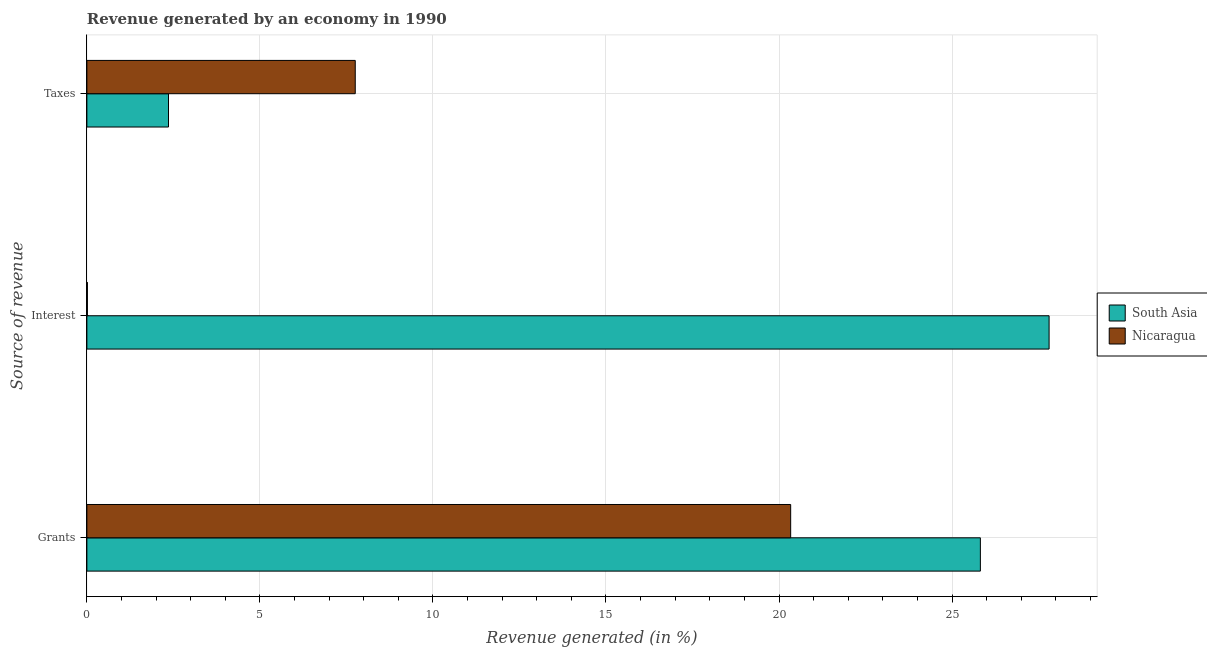How many different coloured bars are there?
Keep it short and to the point. 2. What is the label of the 3rd group of bars from the top?
Offer a very short reply. Grants. What is the percentage of revenue generated by taxes in Nicaragua?
Your response must be concise. 7.75. Across all countries, what is the maximum percentage of revenue generated by grants?
Your response must be concise. 25.82. Across all countries, what is the minimum percentage of revenue generated by taxes?
Your response must be concise. 2.36. In which country was the percentage of revenue generated by interest maximum?
Keep it short and to the point. South Asia. In which country was the percentage of revenue generated by interest minimum?
Your response must be concise. Nicaragua. What is the total percentage of revenue generated by interest in the graph?
Provide a succinct answer. 27.82. What is the difference between the percentage of revenue generated by interest in South Asia and that in Nicaragua?
Give a very brief answer. 27.79. What is the difference between the percentage of revenue generated by interest in Nicaragua and the percentage of revenue generated by grants in South Asia?
Provide a succinct answer. -25.8. What is the average percentage of revenue generated by grants per country?
Make the answer very short. 23.08. What is the difference between the percentage of revenue generated by grants and percentage of revenue generated by interest in Nicaragua?
Provide a succinct answer. 20.32. What is the ratio of the percentage of revenue generated by interest in South Asia to that in Nicaragua?
Provide a succinct answer. 1792.73. Is the percentage of revenue generated by interest in South Asia less than that in Nicaragua?
Your answer should be very brief. No. Is the difference between the percentage of revenue generated by grants in Nicaragua and South Asia greater than the difference between the percentage of revenue generated by interest in Nicaragua and South Asia?
Keep it short and to the point. Yes. What is the difference between the highest and the second highest percentage of revenue generated by taxes?
Provide a succinct answer. 5.4. What is the difference between the highest and the lowest percentage of revenue generated by grants?
Keep it short and to the point. 5.48. In how many countries, is the percentage of revenue generated by interest greater than the average percentage of revenue generated by interest taken over all countries?
Provide a short and direct response. 1. Is the sum of the percentage of revenue generated by taxes in Nicaragua and South Asia greater than the maximum percentage of revenue generated by interest across all countries?
Make the answer very short. No. What does the 1st bar from the top in Taxes represents?
Offer a terse response. Nicaragua. Is it the case that in every country, the sum of the percentage of revenue generated by grants and percentage of revenue generated by interest is greater than the percentage of revenue generated by taxes?
Your answer should be very brief. Yes. How many bars are there?
Provide a short and direct response. 6. How many countries are there in the graph?
Ensure brevity in your answer.  2. What is the difference between two consecutive major ticks on the X-axis?
Your answer should be very brief. 5. Are the values on the major ticks of X-axis written in scientific E-notation?
Offer a very short reply. No. How are the legend labels stacked?
Provide a succinct answer. Vertical. What is the title of the graph?
Your response must be concise. Revenue generated by an economy in 1990. What is the label or title of the X-axis?
Offer a terse response. Revenue generated (in %). What is the label or title of the Y-axis?
Your answer should be compact. Source of revenue. What is the Revenue generated (in %) of South Asia in Grants?
Offer a terse response. 25.82. What is the Revenue generated (in %) in Nicaragua in Grants?
Make the answer very short. 20.34. What is the Revenue generated (in %) in South Asia in Interest?
Your response must be concise. 27.8. What is the Revenue generated (in %) of Nicaragua in Interest?
Your answer should be very brief. 0.02. What is the Revenue generated (in %) in South Asia in Taxes?
Provide a succinct answer. 2.36. What is the Revenue generated (in %) of Nicaragua in Taxes?
Make the answer very short. 7.75. Across all Source of revenue, what is the maximum Revenue generated (in %) in South Asia?
Provide a short and direct response. 27.8. Across all Source of revenue, what is the maximum Revenue generated (in %) in Nicaragua?
Make the answer very short. 20.34. Across all Source of revenue, what is the minimum Revenue generated (in %) of South Asia?
Keep it short and to the point. 2.36. Across all Source of revenue, what is the minimum Revenue generated (in %) in Nicaragua?
Your answer should be compact. 0.02. What is the total Revenue generated (in %) in South Asia in the graph?
Make the answer very short. 55.98. What is the total Revenue generated (in %) of Nicaragua in the graph?
Keep it short and to the point. 28.11. What is the difference between the Revenue generated (in %) of South Asia in Grants and that in Interest?
Your answer should be very brief. -1.99. What is the difference between the Revenue generated (in %) of Nicaragua in Grants and that in Interest?
Your answer should be very brief. 20.32. What is the difference between the Revenue generated (in %) of South Asia in Grants and that in Taxes?
Ensure brevity in your answer.  23.46. What is the difference between the Revenue generated (in %) of Nicaragua in Grants and that in Taxes?
Provide a succinct answer. 12.58. What is the difference between the Revenue generated (in %) of South Asia in Interest and that in Taxes?
Keep it short and to the point. 25.45. What is the difference between the Revenue generated (in %) of Nicaragua in Interest and that in Taxes?
Keep it short and to the point. -7.74. What is the difference between the Revenue generated (in %) in South Asia in Grants and the Revenue generated (in %) in Nicaragua in Interest?
Keep it short and to the point. 25.8. What is the difference between the Revenue generated (in %) of South Asia in Grants and the Revenue generated (in %) of Nicaragua in Taxes?
Offer a very short reply. 18.06. What is the difference between the Revenue generated (in %) of South Asia in Interest and the Revenue generated (in %) of Nicaragua in Taxes?
Provide a short and direct response. 20.05. What is the average Revenue generated (in %) of South Asia per Source of revenue?
Ensure brevity in your answer.  18.66. What is the average Revenue generated (in %) of Nicaragua per Source of revenue?
Your response must be concise. 9.37. What is the difference between the Revenue generated (in %) in South Asia and Revenue generated (in %) in Nicaragua in Grants?
Provide a succinct answer. 5.48. What is the difference between the Revenue generated (in %) of South Asia and Revenue generated (in %) of Nicaragua in Interest?
Keep it short and to the point. 27.79. What is the difference between the Revenue generated (in %) of South Asia and Revenue generated (in %) of Nicaragua in Taxes?
Offer a very short reply. -5.4. What is the ratio of the Revenue generated (in %) of Nicaragua in Grants to that in Interest?
Your answer should be compact. 1311.25. What is the ratio of the Revenue generated (in %) in South Asia in Grants to that in Taxes?
Your answer should be compact. 10.95. What is the ratio of the Revenue generated (in %) in Nicaragua in Grants to that in Taxes?
Make the answer very short. 2.62. What is the ratio of the Revenue generated (in %) in South Asia in Interest to that in Taxes?
Your answer should be compact. 11.79. What is the ratio of the Revenue generated (in %) in Nicaragua in Interest to that in Taxes?
Offer a terse response. 0. What is the difference between the highest and the second highest Revenue generated (in %) of South Asia?
Your answer should be very brief. 1.99. What is the difference between the highest and the second highest Revenue generated (in %) in Nicaragua?
Your response must be concise. 12.58. What is the difference between the highest and the lowest Revenue generated (in %) in South Asia?
Your answer should be compact. 25.45. What is the difference between the highest and the lowest Revenue generated (in %) in Nicaragua?
Ensure brevity in your answer.  20.32. 